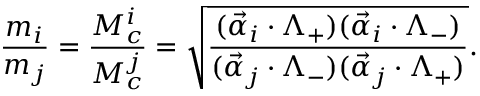<formula> <loc_0><loc_0><loc_500><loc_500>\frac { m _ { i } } { m _ { j } } = \frac { M _ { c } ^ { i } } { M _ { c } ^ { j } } = \sqrt { \frac { ( \vec { \alpha } _ { i } \cdot \Lambda _ { + } ) ( \vec { \alpha } _ { i } \cdot \Lambda _ { - } ) } { ( \vec { \alpha } _ { j } \cdot \Lambda _ { - } ) ( \vec { \alpha } _ { j } \cdot \Lambda _ { + } ) } } .</formula> 